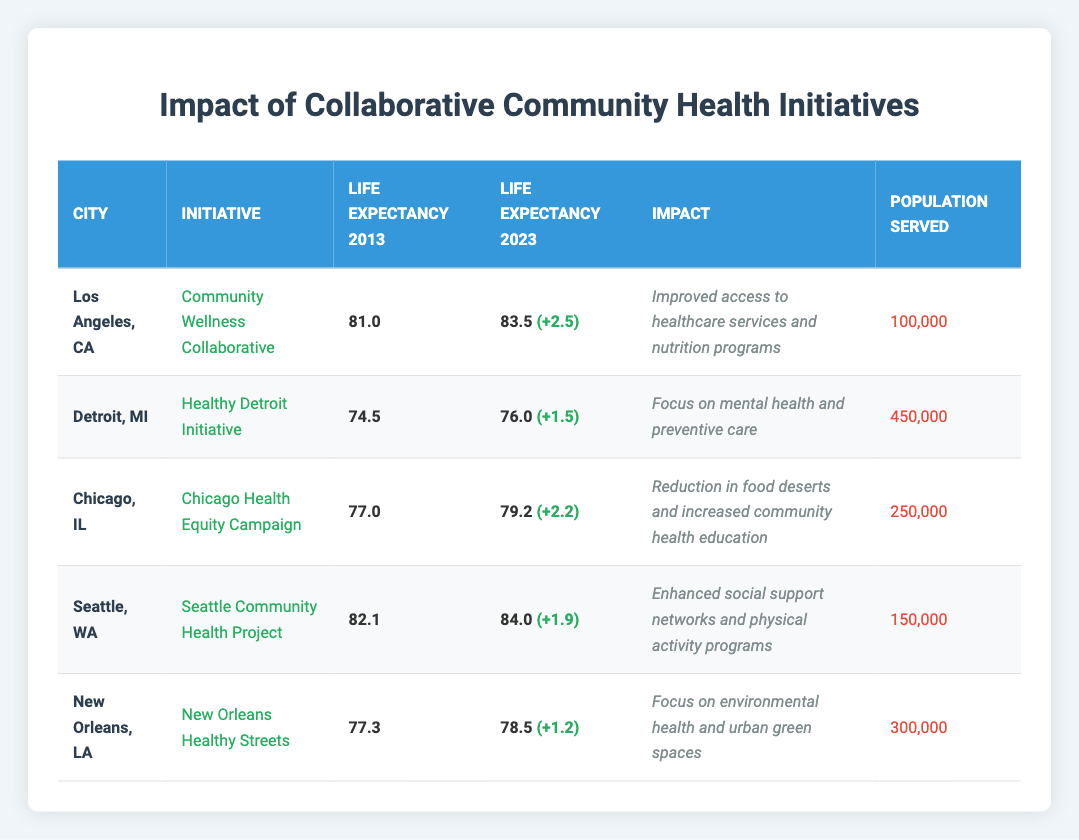What is the life expectancy in Los Angeles, CA in 2023? The table indicates that the life expectancy in Los Angeles, CA in 2023 is listed in the corresponding row under the 'Life Expectancy 2023' column. It shows a value of 83.5.
Answer: 83.5 What was the increase in life expectancy for Detroit, MI over the past decade? To find the increase, subtract the life expectancy for 2013 (74.5) from the life expectancy for 2023 (76.0). The calculation is 76.0 - 74.5 = 1.5.
Answer: 1.5 Which city experienced the largest increase in life expectancy? By reviewing the increases listed in the table for each city: Los Angeles (2.5), Chicago (2.2), Seattle (1.9), Detroit (1.5), and New Orleans (1.2). The largest increase is 2.5 for Los Angeles.
Answer: Los Angeles Is the 'Healthy Detroit Initiative' focused on environmental health? The impact listed for the 'Healthy Detroit Initiative' specifically mentions a focus on mental health and preventive care, not environmental health, which pertains to other initiatives. Therefore, it is not focused on environmental health.
Answer: No What is the average life expectancy for the cities listed in 2023? To find the average for the life expectancy in 2023, sum up the life expectancies: 83.5 (Los Angeles) + 76.0 (Detroit) + 79.2 (Chicago) + 84.0 (Seattle) + 78.5 (New Orleans) = 401.2. Then divide by the number of cities (5). So, the average is 401.2 / 5 = 80.24.
Answer: 80.24 What is the population served by the 'Chicago Health Equity Campaign'? The table lists this information specifically in the row for Chicago under the 'Population Served' column, showing a value of 250,000.
Answer: 250,000 Did Seattle, WA have a higher life expectancy than New Orleans, LA in 2023? The table indicates the life expectancy for Seattle in 2023 is 84.0 while for New Orleans it is 78.5. Thus, Seattle did have a higher life expectancy than New Orleans.
Answer: Yes How many more people does the 'Healthy Detroit Initiative' serve compared to the 'Seattle Community Health Project'? The 'Healthy Detroit Initiative' serves 450,000 people, and the 'Seattle Community Health Project' serves 150,000. The difference is 450,000 - 150,000 = 300,000.
Answer: 300,000 